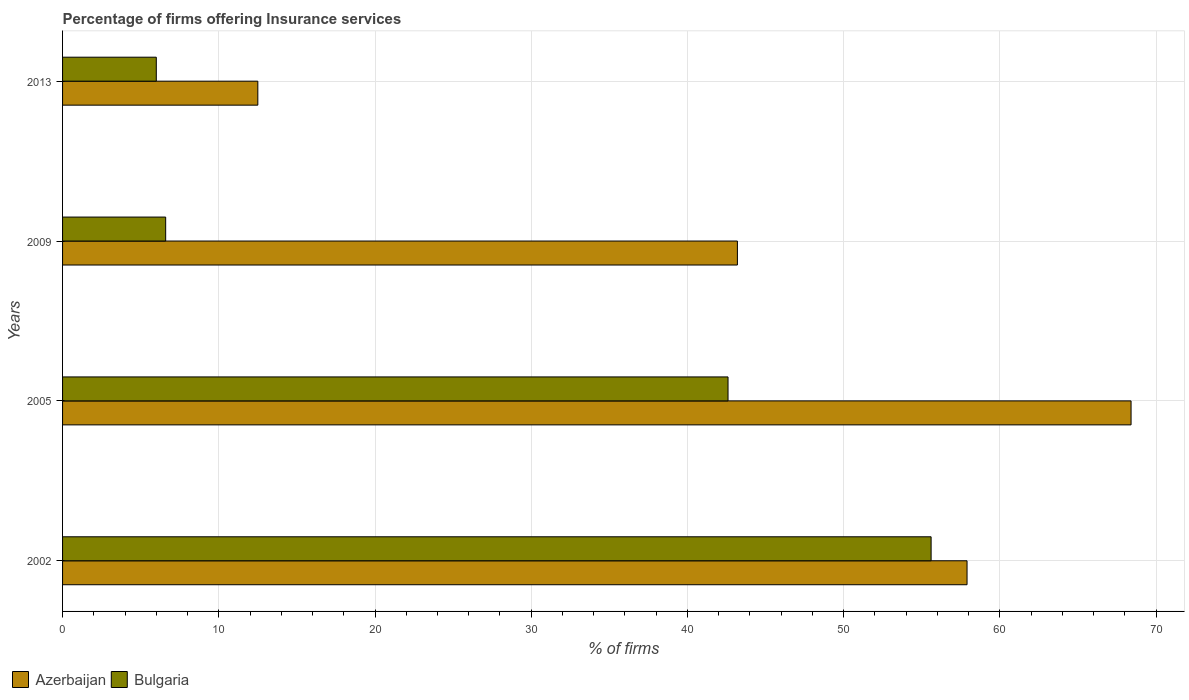How many bars are there on the 1st tick from the top?
Ensure brevity in your answer.  2. What is the percentage of firms offering insurance services in Azerbaijan in 2002?
Offer a terse response. 57.9. Across all years, what is the maximum percentage of firms offering insurance services in Bulgaria?
Ensure brevity in your answer.  55.6. In which year was the percentage of firms offering insurance services in Azerbaijan maximum?
Your response must be concise. 2005. What is the total percentage of firms offering insurance services in Bulgaria in the graph?
Give a very brief answer. 110.8. What is the difference between the percentage of firms offering insurance services in Bulgaria in 2002 and that in 2009?
Give a very brief answer. 49. What is the difference between the percentage of firms offering insurance services in Azerbaijan in 2005 and the percentage of firms offering insurance services in Bulgaria in 2009?
Your answer should be compact. 61.8. What is the average percentage of firms offering insurance services in Bulgaria per year?
Offer a very short reply. 27.7. In the year 2013, what is the difference between the percentage of firms offering insurance services in Azerbaijan and percentage of firms offering insurance services in Bulgaria?
Offer a very short reply. 6.5. In how many years, is the percentage of firms offering insurance services in Bulgaria greater than 30 %?
Offer a terse response. 2. What is the ratio of the percentage of firms offering insurance services in Azerbaijan in 2002 to that in 2013?
Keep it short and to the point. 4.63. What is the difference between the highest and the lowest percentage of firms offering insurance services in Bulgaria?
Offer a terse response. 49.6. Is the sum of the percentage of firms offering insurance services in Azerbaijan in 2009 and 2013 greater than the maximum percentage of firms offering insurance services in Bulgaria across all years?
Your response must be concise. Yes. What does the 2nd bar from the top in 2005 represents?
Offer a very short reply. Azerbaijan. What does the 1st bar from the bottom in 2013 represents?
Your answer should be compact. Azerbaijan. Are all the bars in the graph horizontal?
Give a very brief answer. Yes. How many years are there in the graph?
Ensure brevity in your answer.  4. Where does the legend appear in the graph?
Your response must be concise. Bottom left. How many legend labels are there?
Offer a very short reply. 2. How are the legend labels stacked?
Offer a terse response. Horizontal. What is the title of the graph?
Offer a very short reply. Percentage of firms offering Insurance services. What is the label or title of the X-axis?
Make the answer very short. % of firms. What is the % of firms of Azerbaijan in 2002?
Your answer should be compact. 57.9. What is the % of firms in Bulgaria in 2002?
Offer a terse response. 55.6. What is the % of firms in Azerbaijan in 2005?
Offer a very short reply. 68.4. What is the % of firms of Bulgaria in 2005?
Keep it short and to the point. 42.6. What is the % of firms of Azerbaijan in 2009?
Offer a terse response. 43.2. Across all years, what is the maximum % of firms in Azerbaijan?
Keep it short and to the point. 68.4. Across all years, what is the maximum % of firms of Bulgaria?
Provide a short and direct response. 55.6. What is the total % of firms of Azerbaijan in the graph?
Your response must be concise. 182. What is the total % of firms in Bulgaria in the graph?
Provide a short and direct response. 110.8. What is the difference between the % of firms of Azerbaijan in 2002 and that in 2005?
Ensure brevity in your answer.  -10.5. What is the difference between the % of firms in Bulgaria in 2002 and that in 2005?
Your response must be concise. 13. What is the difference between the % of firms of Azerbaijan in 2002 and that in 2013?
Your answer should be very brief. 45.4. What is the difference between the % of firms in Bulgaria in 2002 and that in 2013?
Offer a very short reply. 49.6. What is the difference between the % of firms of Azerbaijan in 2005 and that in 2009?
Your answer should be compact. 25.2. What is the difference between the % of firms in Azerbaijan in 2005 and that in 2013?
Ensure brevity in your answer.  55.9. What is the difference between the % of firms of Bulgaria in 2005 and that in 2013?
Provide a succinct answer. 36.6. What is the difference between the % of firms of Azerbaijan in 2009 and that in 2013?
Keep it short and to the point. 30.7. What is the difference between the % of firms in Azerbaijan in 2002 and the % of firms in Bulgaria in 2009?
Provide a succinct answer. 51.3. What is the difference between the % of firms of Azerbaijan in 2002 and the % of firms of Bulgaria in 2013?
Keep it short and to the point. 51.9. What is the difference between the % of firms of Azerbaijan in 2005 and the % of firms of Bulgaria in 2009?
Give a very brief answer. 61.8. What is the difference between the % of firms of Azerbaijan in 2005 and the % of firms of Bulgaria in 2013?
Your response must be concise. 62.4. What is the difference between the % of firms in Azerbaijan in 2009 and the % of firms in Bulgaria in 2013?
Ensure brevity in your answer.  37.2. What is the average % of firms of Azerbaijan per year?
Keep it short and to the point. 45.5. What is the average % of firms of Bulgaria per year?
Provide a succinct answer. 27.7. In the year 2002, what is the difference between the % of firms in Azerbaijan and % of firms in Bulgaria?
Your answer should be very brief. 2.3. In the year 2005, what is the difference between the % of firms of Azerbaijan and % of firms of Bulgaria?
Give a very brief answer. 25.8. In the year 2009, what is the difference between the % of firms of Azerbaijan and % of firms of Bulgaria?
Provide a succinct answer. 36.6. What is the ratio of the % of firms of Azerbaijan in 2002 to that in 2005?
Provide a short and direct response. 0.85. What is the ratio of the % of firms of Bulgaria in 2002 to that in 2005?
Provide a succinct answer. 1.31. What is the ratio of the % of firms of Azerbaijan in 2002 to that in 2009?
Give a very brief answer. 1.34. What is the ratio of the % of firms in Bulgaria in 2002 to that in 2009?
Offer a terse response. 8.42. What is the ratio of the % of firms in Azerbaijan in 2002 to that in 2013?
Your answer should be compact. 4.63. What is the ratio of the % of firms of Bulgaria in 2002 to that in 2013?
Make the answer very short. 9.27. What is the ratio of the % of firms of Azerbaijan in 2005 to that in 2009?
Your answer should be very brief. 1.58. What is the ratio of the % of firms in Bulgaria in 2005 to that in 2009?
Provide a short and direct response. 6.45. What is the ratio of the % of firms of Azerbaijan in 2005 to that in 2013?
Make the answer very short. 5.47. What is the ratio of the % of firms in Azerbaijan in 2009 to that in 2013?
Give a very brief answer. 3.46. What is the difference between the highest and the second highest % of firms of Azerbaijan?
Offer a terse response. 10.5. What is the difference between the highest and the lowest % of firms of Azerbaijan?
Your response must be concise. 55.9. What is the difference between the highest and the lowest % of firms of Bulgaria?
Your answer should be very brief. 49.6. 